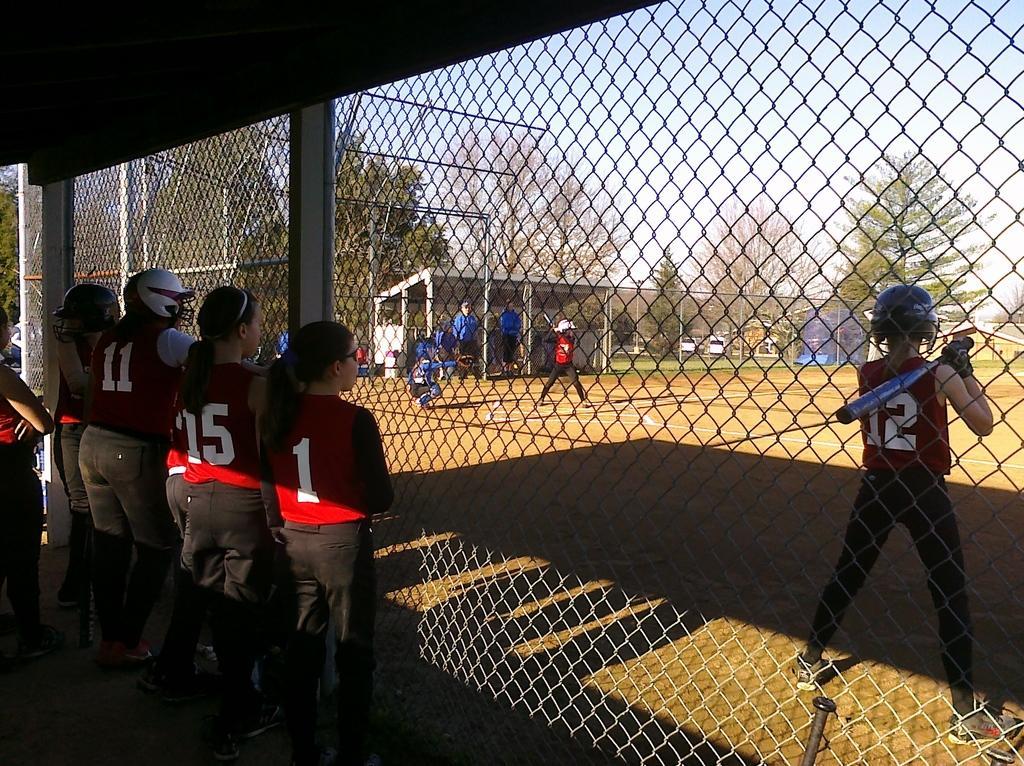How would you summarize this image in a sentence or two? In this image I can see on the left side 4 persons are standing they wore red color t-shirts and black color trousers. This is an iron net, on the right side a man is playing the baseball. This person wore red color t-shirt and black color trouser. In the middle there are trees, at the top it is the sky. 